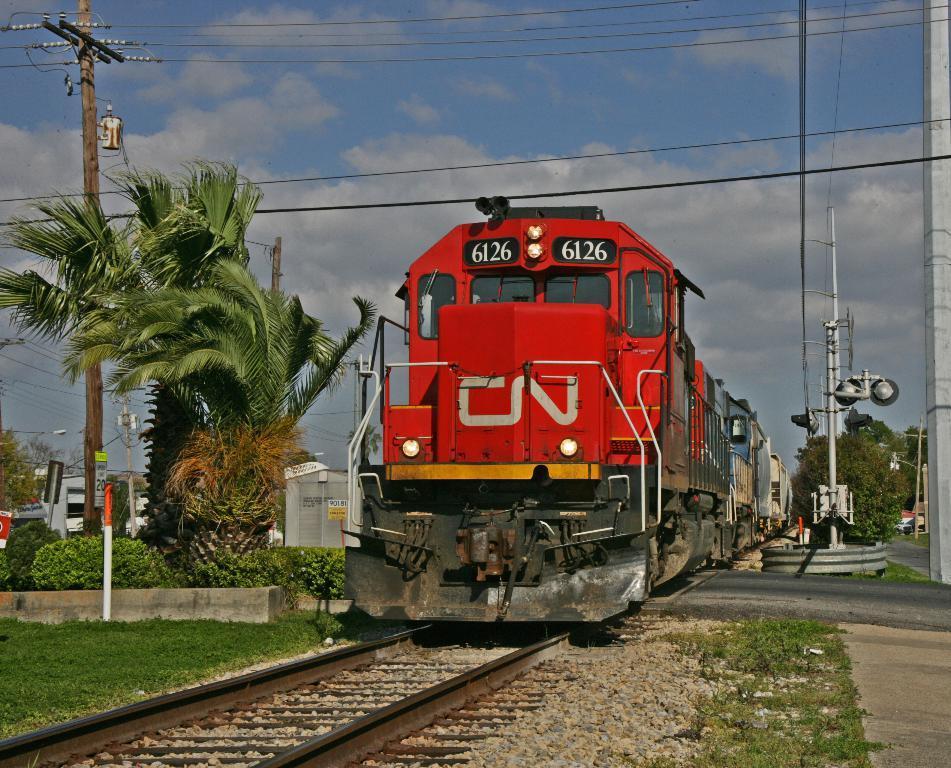How would you summarize this image in a sentence or two? In this image there is a train on the railway track , trees, plants, grass, poles, and in the background there is sky. 